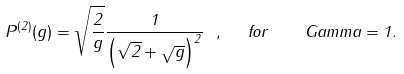<formula> <loc_0><loc_0><loc_500><loc_500>P ^ { ( 2 ) } ( g ) = \sqrt { \frac { 2 } { g } } \frac { 1 } { \left ( \sqrt { 2 } + \sqrt { g } \right ) ^ { 2 } } \ , \ \ f o r \quad G a m m a = 1 .</formula> 